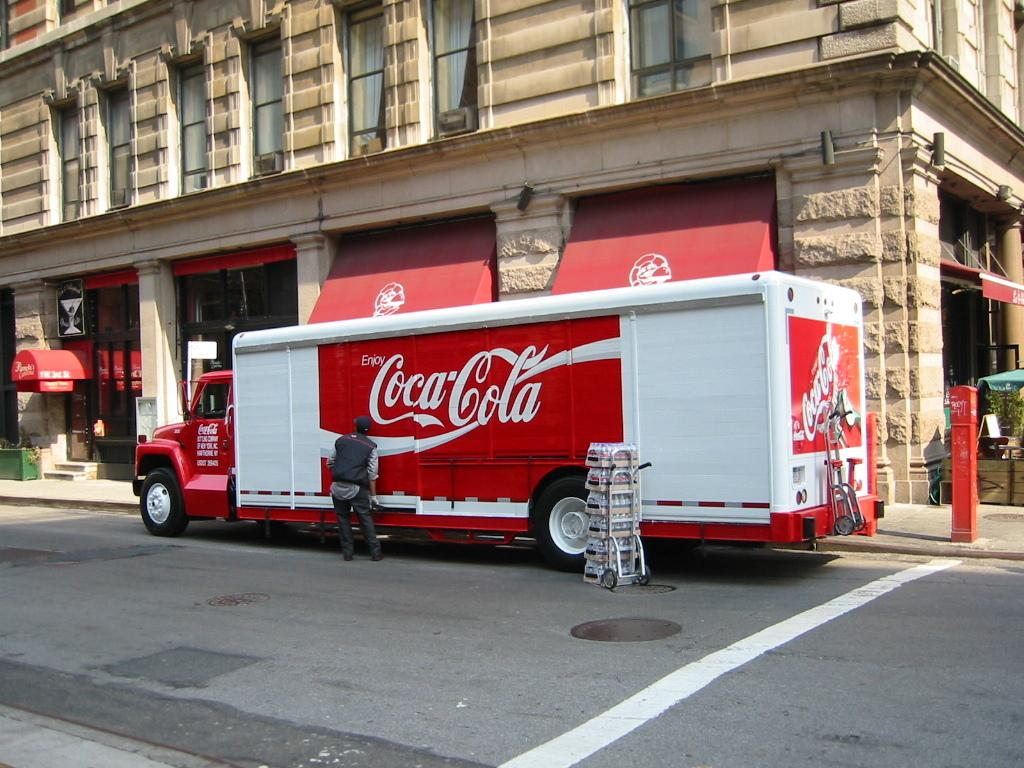What is the main subject of the image? The main subject of the image is a truck on a road. Is there anyone near the truck? Yes, there is a person standing beside the truck. What can be seen in the background of the image? There is a building in the background of the image. What type of seed is being planted by the person standing beside the truck? There is no seed or planting activity depicted in the image; it only shows a truck on a road and a person standing beside it. 